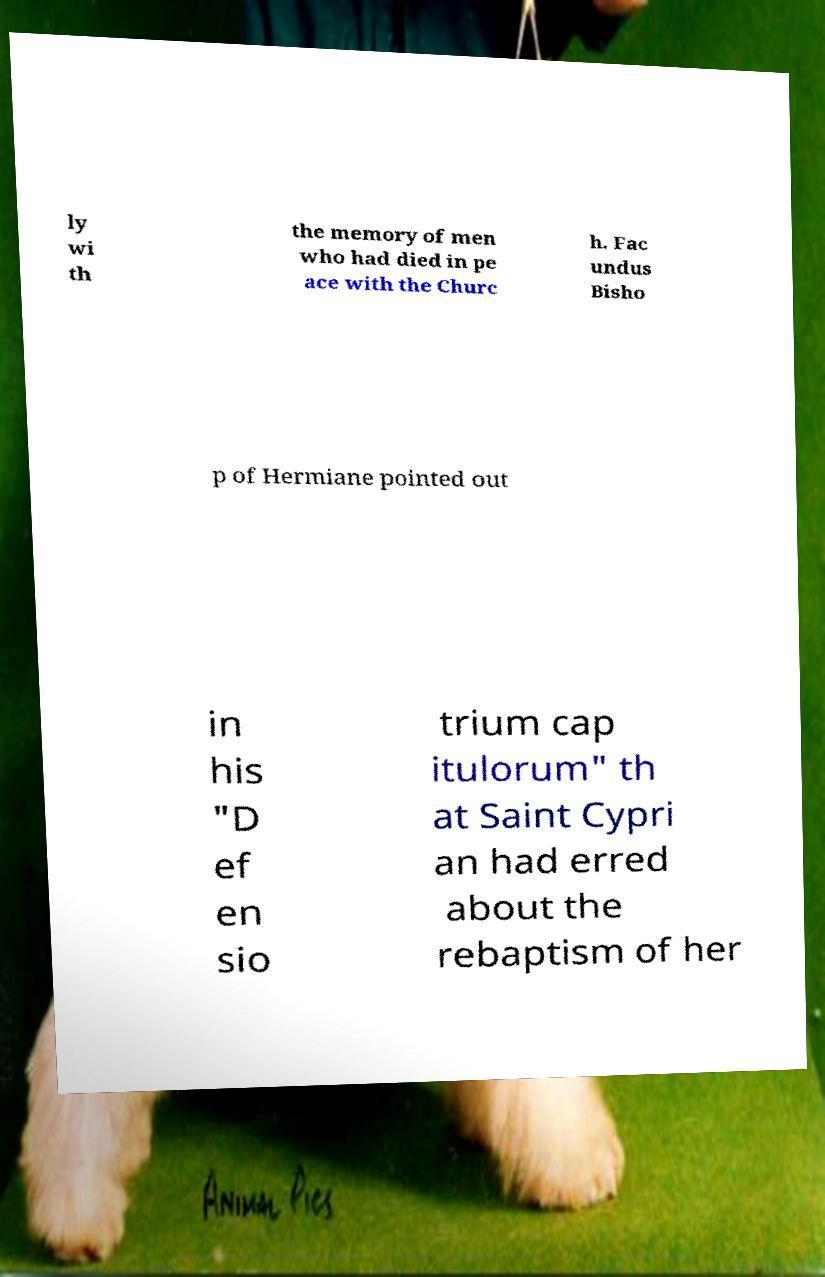What messages or text are displayed in this image? I need them in a readable, typed format. ly wi th the memory of men who had died in pe ace with the Churc h. Fac undus Bisho p of Hermiane pointed out in his "D ef en sio trium cap itulorum" th at Saint Cypri an had erred about the rebaptism of her 